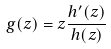<formula> <loc_0><loc_0><loc_500><loc_500>g ( z ) = z \frac { h ^ { \prime } ( z ) } { h ( z ) }</formula> 